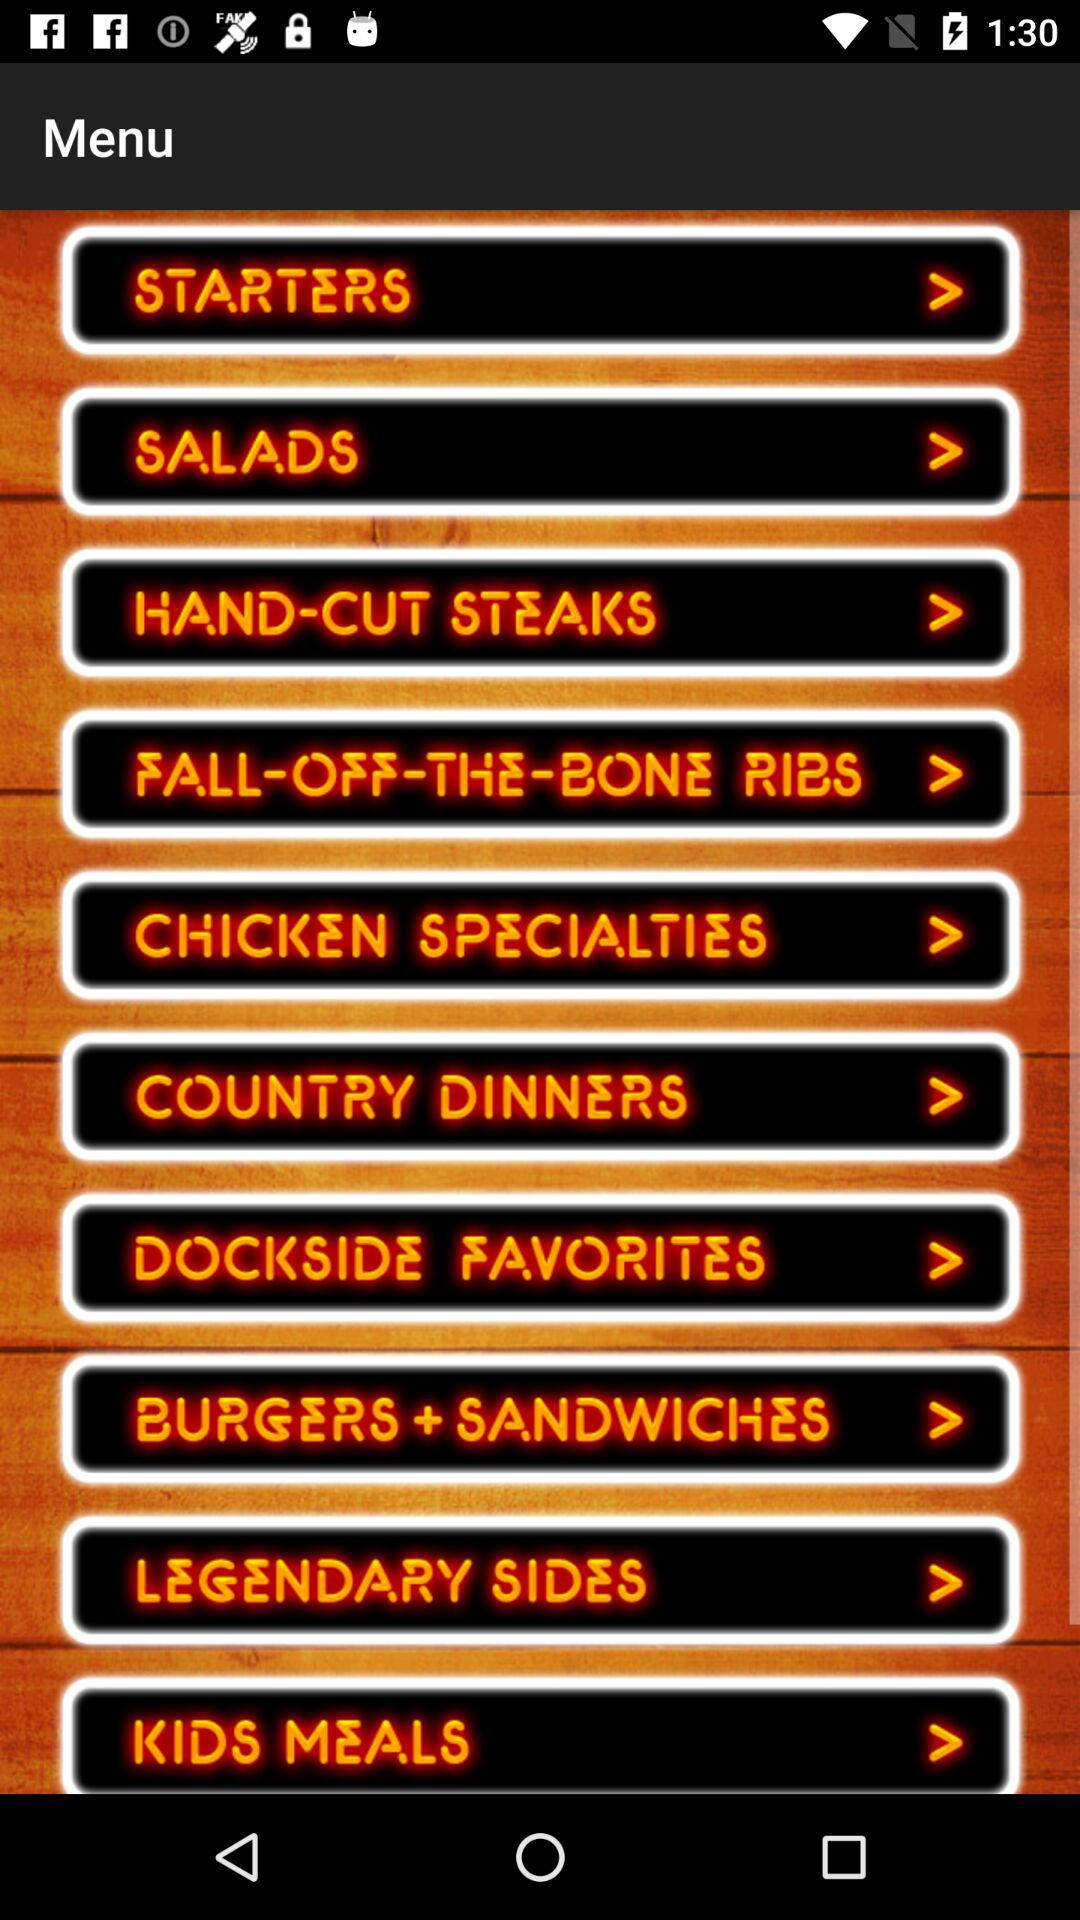How many categories of food are there on this menu?
Answer the question using a single word or phrase. 10 